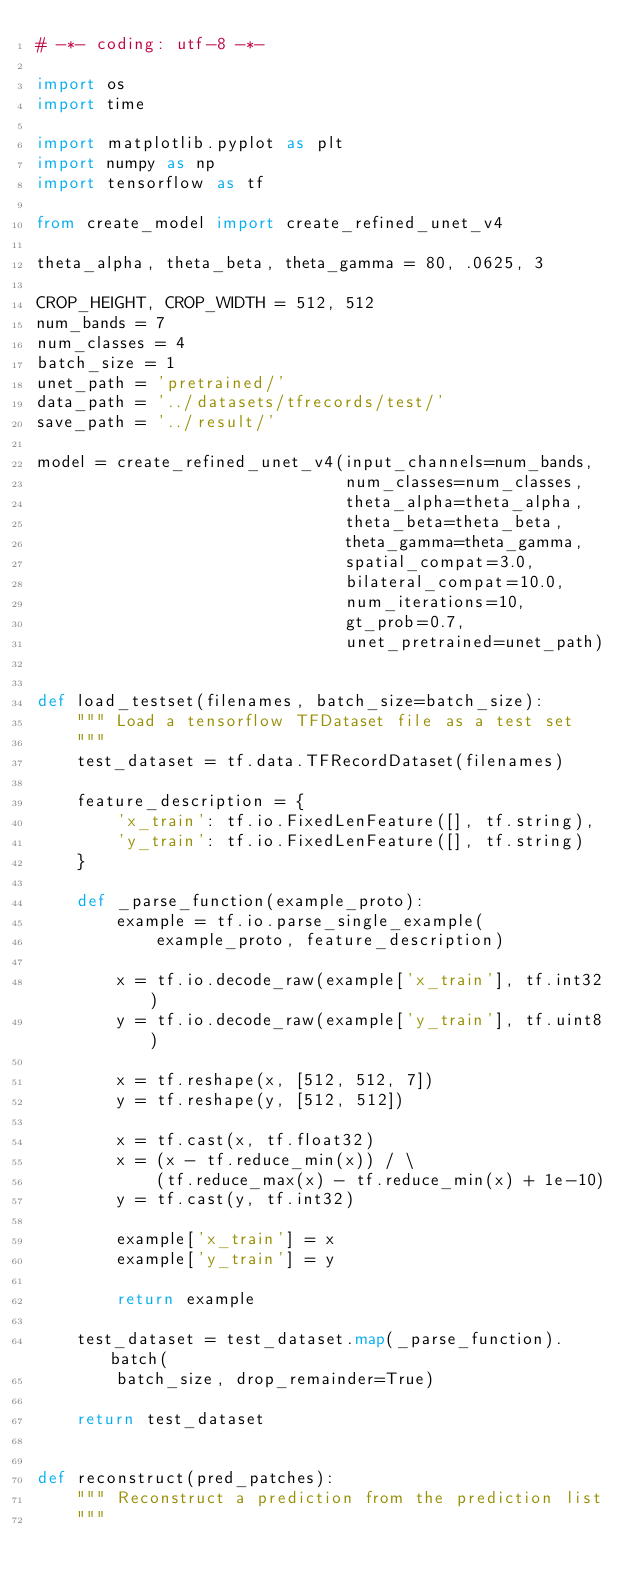Convert code to text. <code><loc_0><loc_0><loc_500><loc_500><_Python_># -*- coding: utf-8 -*-

import os
import time

import matplotlib.pyplot as plt
import numpy as np
import tensorflow as tf

from create_model import create_refined_unet_v4

theta_alpha, theta_beta, theta_gamma = 80, .0625, 3

CROP_HEIGHT, CROP_WIDTH = 512, 512
num_bands = 7
num_classes = 4
batch_size = 1
unet_path = 'pretrained/'
data_path = '../datasets/tfrecords/test/'
save_path = '../result/'

model = create_refined_unet_v4(input_channels=num_bands,
                               num_classes=num_classes,
                               theta_alpha=theta_alpha,
                               theta_beta=theta_beta,
                               theta_gamma=theta_gamma,
                               spatial_compat=3.0,
                               bilateral_compat=10.0,
                               num_iterations=10,
                               gt_prob=0.7,
                               unet_pretrained=unet_path)


def load_testset(filenames, batch_size=batch_size):
    """ Load a tensorflow TFDataset file as a test set
    """
    test_dataset = tf.data.TFRecordDataset(filenames)

    feature_description = {
        'x_train': tf.io.FixedLenFeature([], tf.string),
        'y_train': tf.io.FixedLenFeature([], tf.string)
    }

    def _parse_function(example_proto):
        example = tf.io.parse_single_example(
            example_proto, feature_description)

        x = tf.io.decode_raw(example['x_train'], tf.int32)
        y = tf.io.decode_raw(example['y_train'], tf.uint8)

        x = tf.reshape(x, [512, 512, 7])
        y = tf.reshape(y, [512, 512])

        x = tf.cast(x, tf.float32)
        x = (x - tf.reduce_min(x)) / \
            (tf.reduce_max(x) - tf.reduce_min(x) + 1e-10)
        y = tf.cast(y, tf.int32)

        example['x_train'] = x
        example['y_train'] = y

        return example

    test_dataset = test_dataset.map(_parse_function).batch(
        batch_size, drop_remainder=True)

    return test_dataset


def reconstruct(pred_patches):
    """ Reconstruct a prediction from the prediction list
    """</code> 